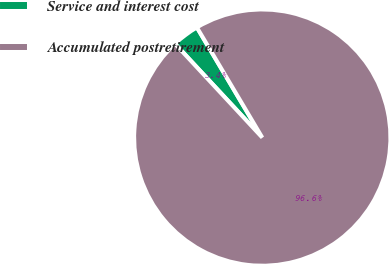Convert chart to OTSL. <chart><loc_0><loc_0><loc_500><loc_500><pie_chart><fcel>Service and interest cost<fcel>Accumulated postretirement<nl><fcel>3.4%<fcel>96.6%<nl></chart> 